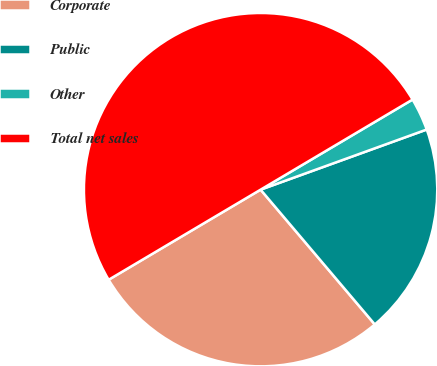<chart> <loc_0><loc_0><loc_500><loc_500><pie_chart><fcel>Corporate<fcel>Public<fcel>Other<fcel>Total net sales<nl><fcel>27.67%<fcel>19.34%<fcel>2.99%<fcel>50.0%<nl></chart> 